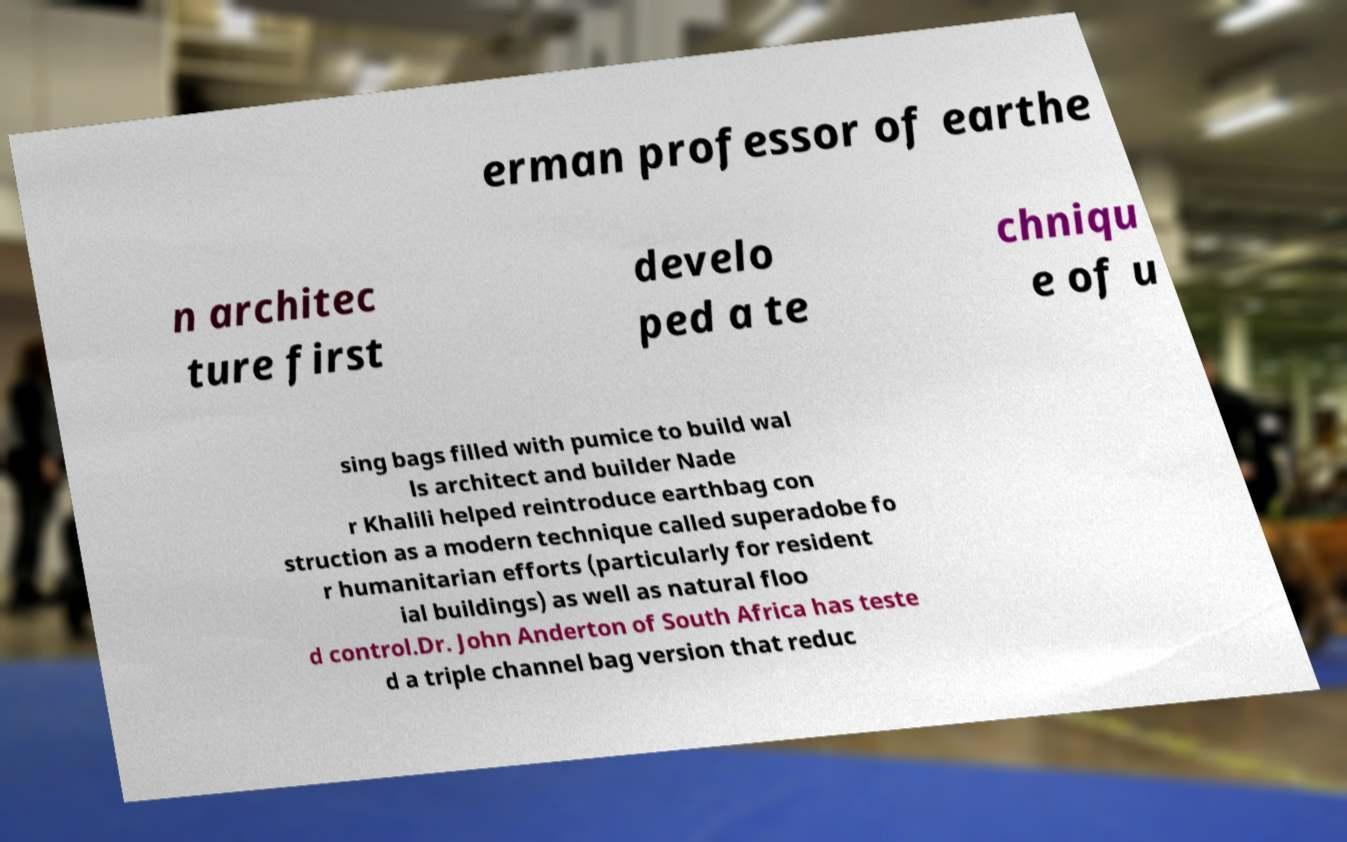Could you extract and type out the text from this image? erman professor of earthe n architec ture first develo ped a te chniqu e of u sing bags filled with pumice to build wal ls architect and builder Nade r Khalili helped reintroduce earthbag con struction as a modern technique called superadobe fo r humanitarian efforts (particularly for resident ial buildings) as well as natural floo d control.Dr. John Anderton of South Africa has teste d a triple channel bag version that reduc 